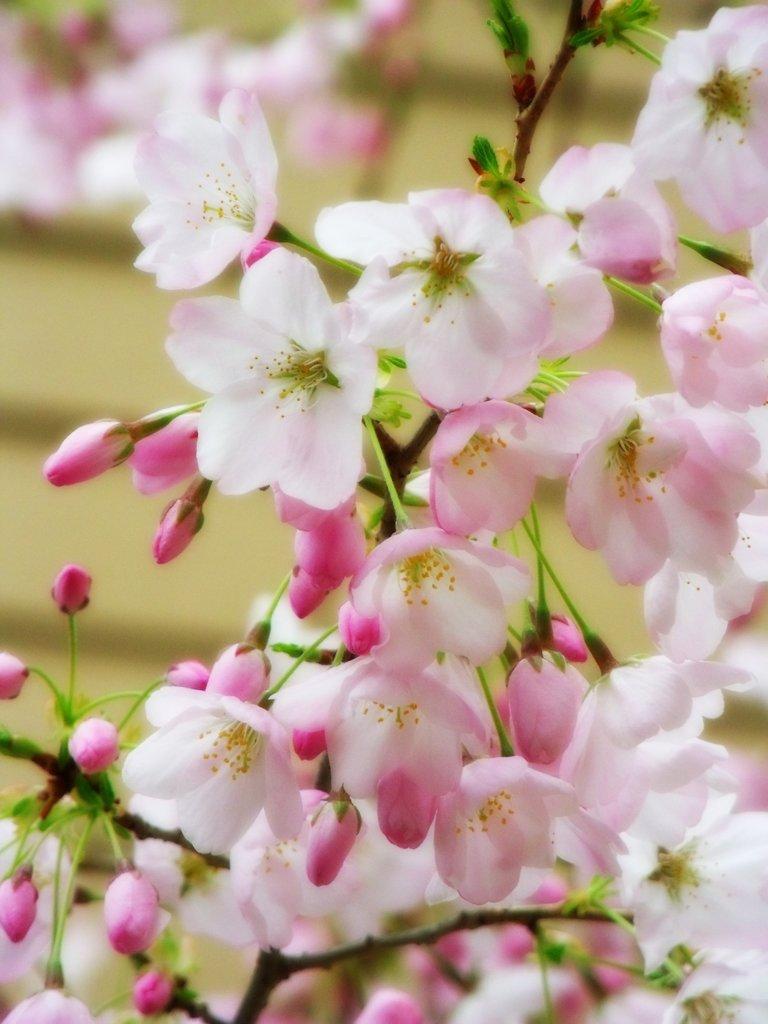Describe this image in one or two sentences. In this image we can see a plant with flowers and buds. In the background the image is blur but we can see flowers. 